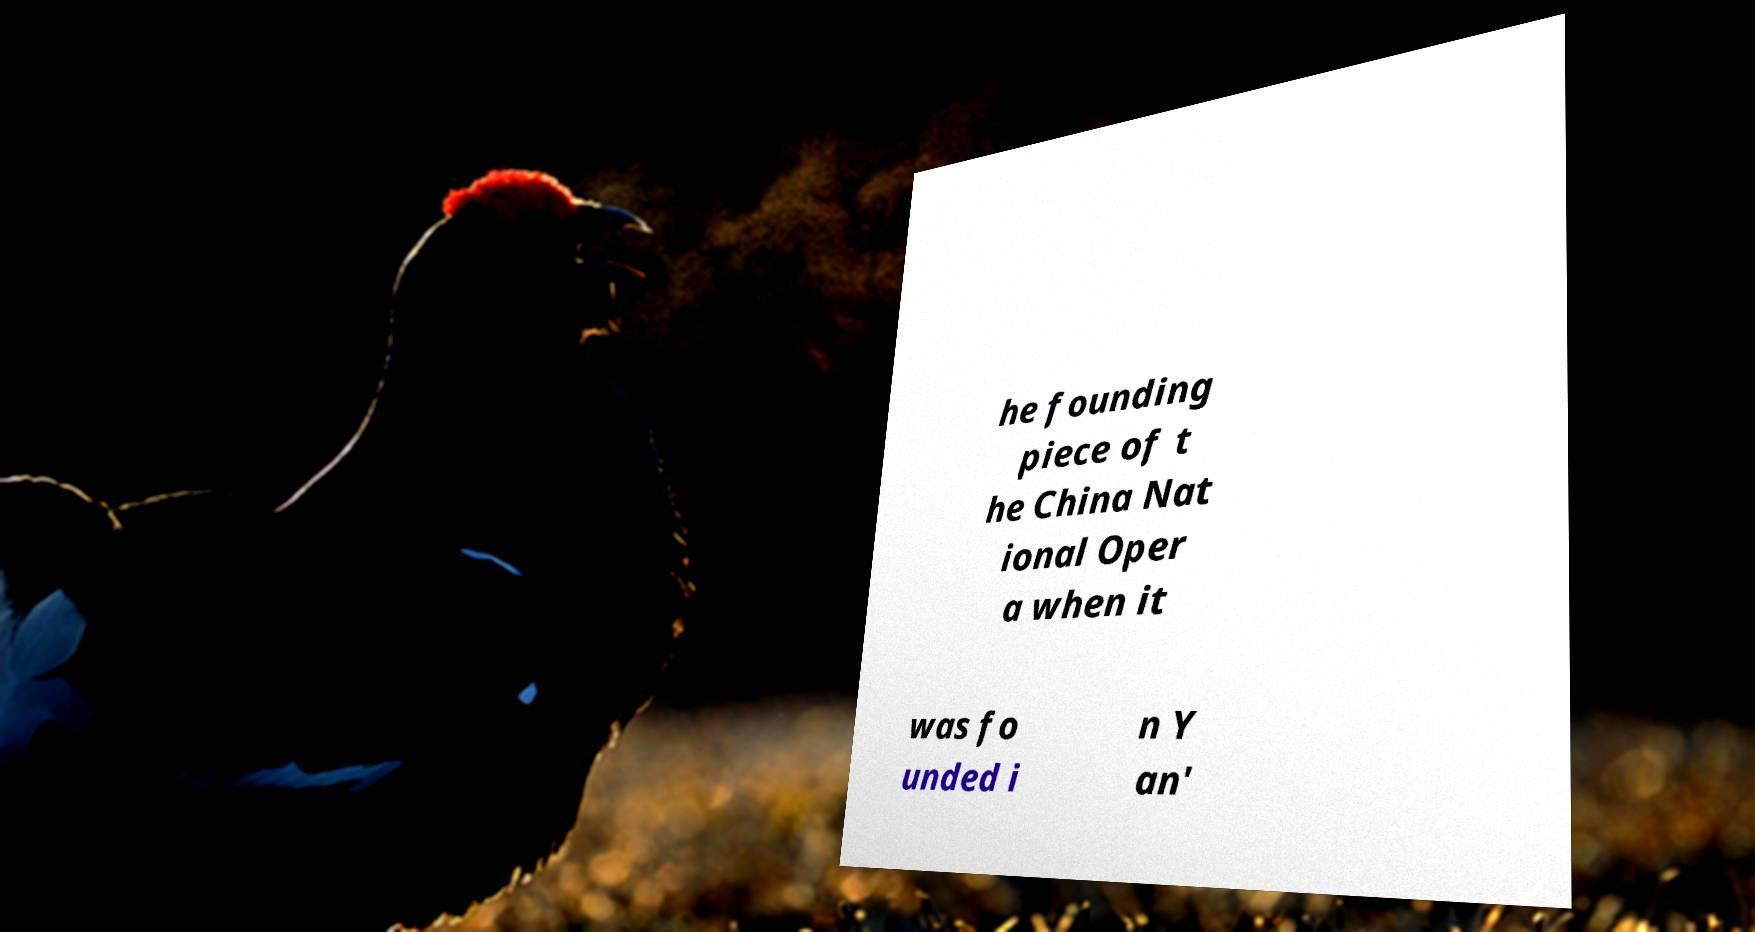For documentation purposes, I need the text within this image transcribed. Could you provide that? he founding piece of t he China Nat ional Oper a when it was fo unded i n Y an' 